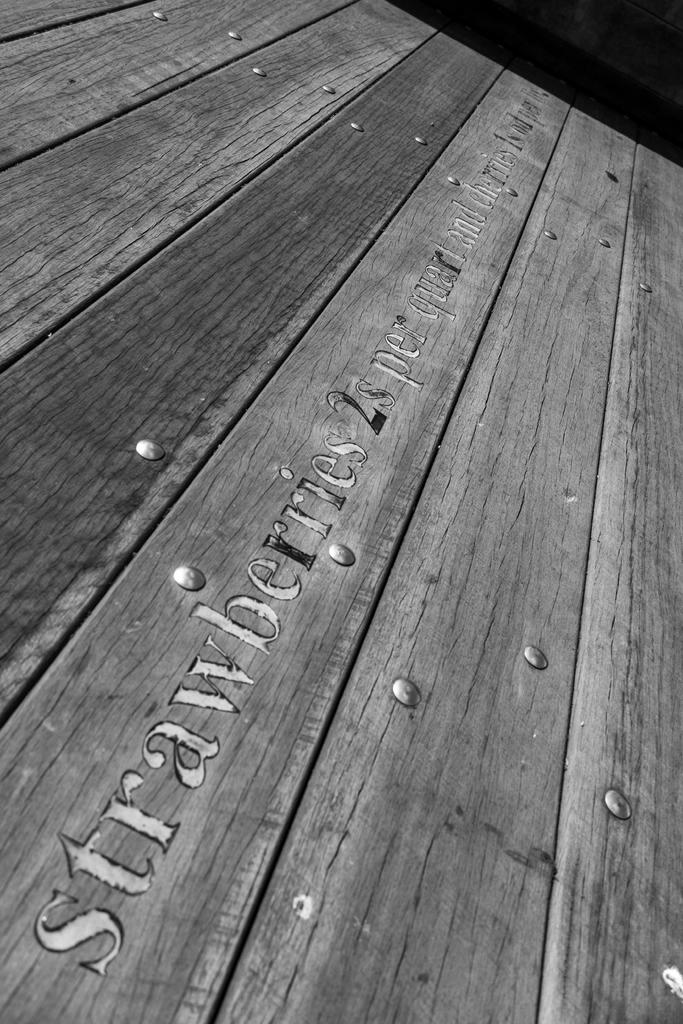Provide a one-sentence caption for the provided image. A wooden sign has the words "strawberries 2s per quart" written on it. 